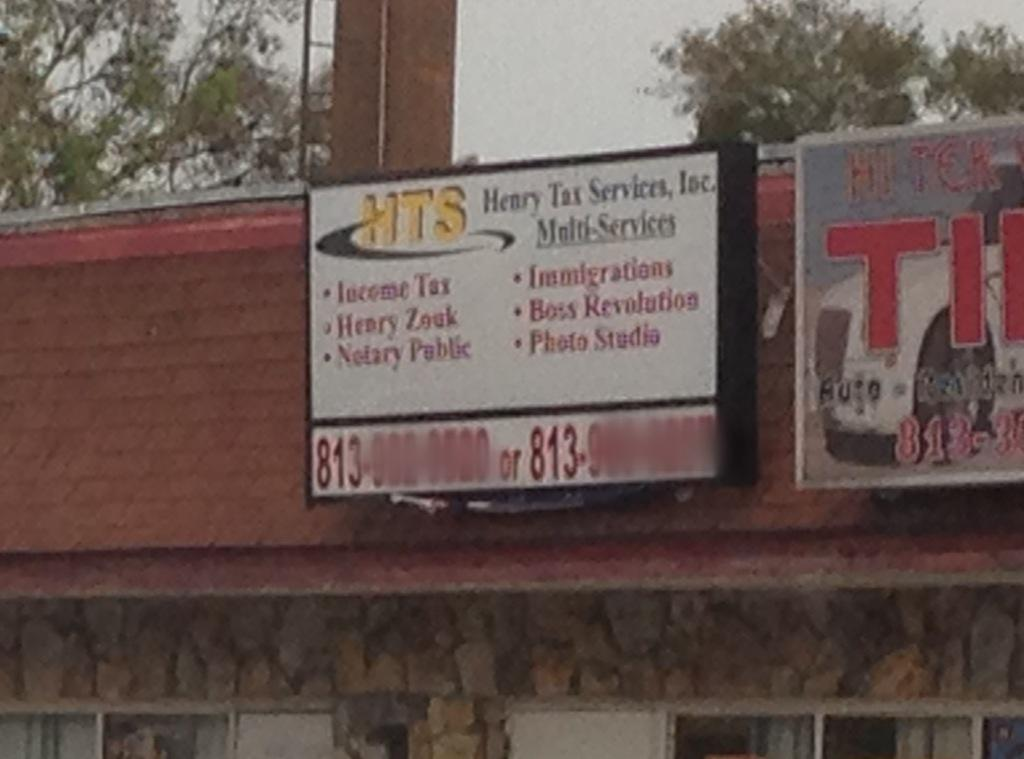<image>
Present a compact description of the photo's key features. A sign on a building reads Henry Tax Services Inc. 